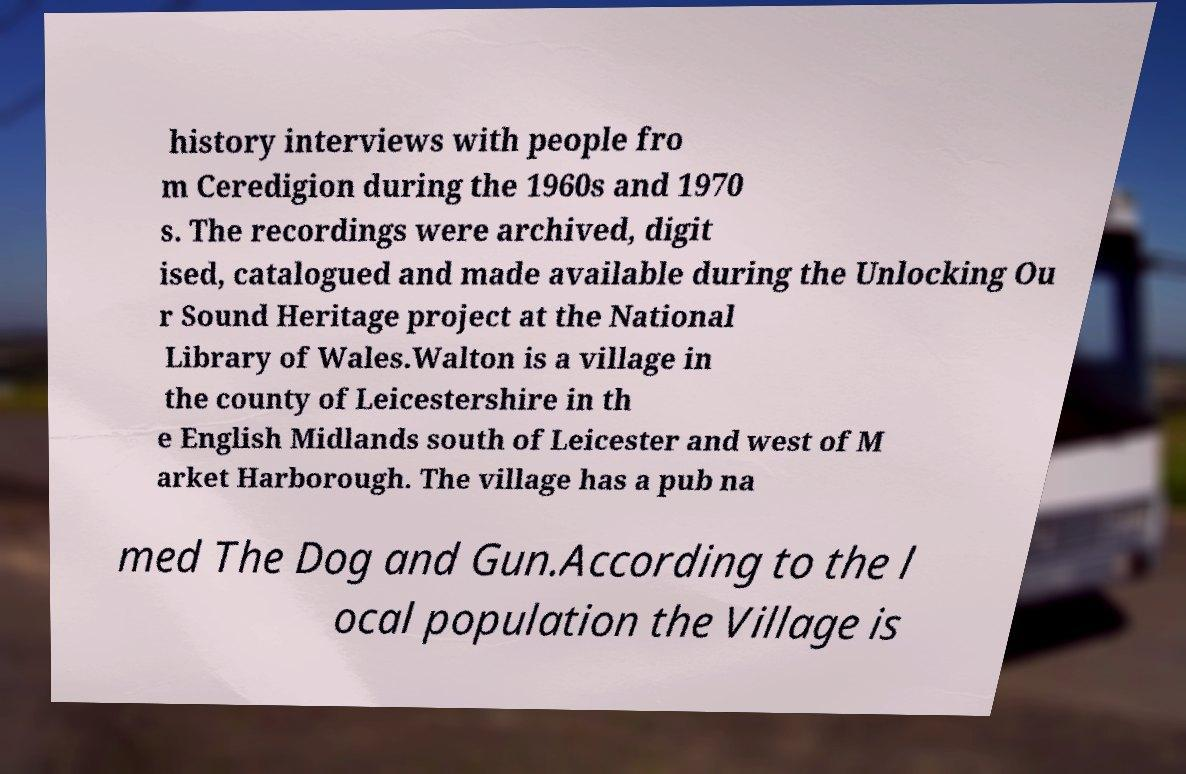There's text embedded in this image that I need extracted. Can you transcribe it verbatim? history interviews with people fro m Ceredigion during the 1960s and 1970 s. The recordings were archived, digit ised, catalogued and made available during the Unlocking Ou r Sound Heritage project at the National Library of Wales.Walton is a village in the county of Leicestershire in th e English Midlands south of Leicester and west of M arket Harborough. The village has a pub na med The Dog and Gun.According to the l ocal population the Village is 